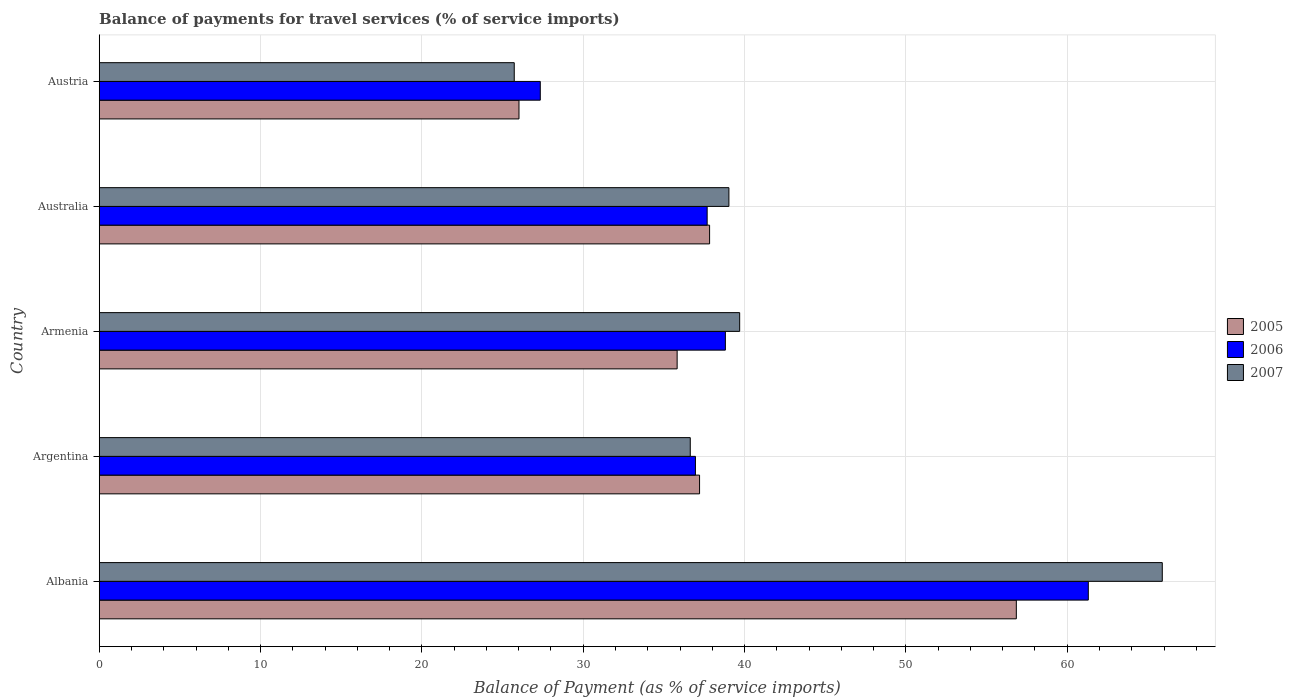How many different coloured bars are there?
Ensure brevity in your answer.  3. Are the number of bars per tick equal to the number of legend labels?
Offer a terse response. Yes. Are the number of bars on each tick of the Y-axis equal?
Offer a terse response. Yes. How many bars are there on the 1st tick from the bottom?
Provide a short and direct response. 3. What is the label of the 5th group of bars from the top?
Provide a succinct answer. Albania. What is the balance of payments for travel services in 2006 in Argentina?
Provide a short and direct response. 36.96. Across all countries, what is the maximum balance of payments for travel services in 2006?
Provide a succinct answer. 61.31. Across all countries, what is the minimum balance of payments for travel services in 2005?
Your answer should be very brief. 26.02. In which country was the balance of payments for travel services in 2006 maximum?
Offer a very short reply. Albania. What is the total balance of payments for travel services in 2006 in the graph?
Keep it short and to the point. 202.1. What is the difference between the balance of payments for travel services in 2005 in Argentina and that in Austria?
Make the answer very short. 11.19. What is the difference between the balance of payments for travel services in 2006 in Armenia and the balance of payments for travel services in 2005 in Austria?
Your answer should be very brief. 12.79. What is the average balance of payments for travel services in 2007 per country?
Keep it short and to the point. 41.4. What is the difference between the balance of payments for travel services in 2005 and balance of payments for travel services in 2006 in Austria?
Your response must be concise. -1.32. In how many countries, is the balance of payments for travel services in 2007 greater than 8 %?
Your answer should be compact. 5. What is the ratio of the balance of payments for travel services in 2006 in Argentina to that in Austria?
Keep it short and to the point. 1.35. Is the balance of payments for travel services in 2007 in Argentina less than that in Austria?
Offer a very short reply. No. What is the difference between the highest and the second highest balance of payments for travel services in 2007?
Your answer should be very brief. 26.19. What is the difference between the highest and the lowest balance of payments for travel services in 2005?
Provide a succinct answer. 30.83. What does the 1st bar from the bottom in Albania represents?
Your answer should be compact. 2005. Is it the case that in every country, the sum of the balance of payments for travel services in 2007 and balance of payments for travel services in 2006 is greater than the balance of payments for travel services in 2005?
Ensure brevity in your answer.  Yes. Are all the bars in the graph horizontal?
Provide a short and direct response. Yes. What is the difference between two consecutive major ticks on the X-axis?
Your response must be concise. 10. Are the values on the major ticks of X-axis written in scientific E-notation?
Your answer should be very brief. No. Where does the legend appear in the graph?
Ensure brevity in your answer.  Center right. What is the title of the graph?
Ensure brevity in your answer.  Balance of payments for travel services (% of service imports). What is the label or title of the X-axis?
Make the answer very short. Balance of Payment (as % of service imports). What is the Balance of Payment (as % of service imports) of 2005 in Albania?
Your answer should be very brief. 56.85. What is the Balance of Payment (as % of service imports) in 2006 in Albania?
Give a very brief answer. 61.31. What is the Balance of Payment (as % of service imports) in 2007 in Albania?
Your answer should be very brief. 65.89. What is the Balance of Payment (as % of service imports) of 2005 in Argentina?
Ensure brevity in your answer.  37.21. What is the Balance of Payment (as % of service imports) of 2006 in Argentina?
Ensure brevity in your answer.  36.96. What is the Balance of Payment (as % of service imports) of 2007 in Argentina?
Ensure brevity in your answer.  36.64. What is the Balance of Payment (as % of service imports) in 2005 in Armenia?
Provide a succinct answer. 35.82. What is the Balance of Payment (as % of service imports) of 2006 in Armenia?
Keep it short and to the point. 38.81. What is the Balance of Payment (as % of service imports) in 2007 in Armenia?
Your response must be concise. 39.7. What is the Balance of Payment (as % of service imports) in 2005 in Australia?
Keep it short and to the point. 37.83. What is the Balance of Payment (as % of service imports) in 2006 in Australia?
Your answer should be very brief. 37.68. What is the Balance of Payment (as % of service imports) in 2007 in Australia?
Offer a very short reply. 39.03. What is the Balance of Payment (as % of service imports) in 2005 in Austria?
Your answer should be compact. 26.02. What is the Balance of Payment (as % of service imports) of 2006 in Austria?
Keep it short and to the point. 27.34. What is the Balance of Payment (as % of service imports) of 2007 in Austria?
Offer a very short reply. 25.73. Across all countries, what is the maximum Balance of Payment (as % of service imports) of 2005?
Offer a terse response. 56.85. Across all countries, what is the maximum Balance of Payment (as % of service imports) of 2006?
Offer a very short reply. 61.31. Across all countries, what is the maximum Balance of Payment (as % of service imports) of 2007?
Ensure brevity in your answer.  65.89. Across all countries, what is the minimum Balance of Payment (as % of service imports) in 2005?
Keep it short and to the point. 26.02. Across all countries, what is the minimum Balance of Payment (as % of service imports) of 2006?
Your response must be concise. 27.34. Across all countries, what is the minimum Balance of Payment (as % of service imports) of 2007?
Your response must be concise. 25.73. What is the total Balance of Payment (as % of service imports) of 2005 in the graph?
Keep it short and to the point. 193.73. What is the total Balance of Payment (as % of service imports) in 2006 in the graph?
Your answer should be compact. 202.1. What is the total Balance of Payment (as % of service imports) of 2007 in the graph?
Provide a short and direct response. 206.98. What is the difference between the Balance of Payment (as % of service imports) in 2005 in Albania and that in Argentina?
Make the answer very short. 19.64. What is the difference between the Balance of Payment (as % of service imports) in 2006 in Albania and that in Argentina?
Offer a very short reply. 24.35. What is the difference between the Balance of Payment (as % of service imports) of 2007 in Albania and that in Argentina?
Your response must be concise. 29.26. What is the difference between the Balance of Payment (as % of service imports) of 2005 in Albania and that in Armenia?
Keep it short and to the point. 21.02. What is the difference between the Balance of Payment (as % of service imports) in 2006 in Albania and that in Armenia?
Give a very brief answer. 22.5. What is the difference between the Balance of Payment (as % of service imports) of 2007 in Albania and that in Armenia?
Your answer should be compact. 26.19. What is the difference between the Balance of Payment (as % of service imports) of 2005 in Albania and that in Australia?
Offer a terse response. 19.01. What is the difference between the Balance of Payment (as % of service imports) of 2006 in Albania and that in Australia?
Give a very brief answer. 23.63. What is the difference between the Balance of Payment (as % of service imports) of 2007 in Albania and that in Australia?
Provide a short and direct response. 26.86. What is the difference between the Balance of Payment (as % of service imports) in 2005 in Albania and that in Austria?
Your response must be concise. 30.83. What is the difference between the Balance of Payment (as % of service imports) in 2006 in Albania and that in Austria?
Make the answer very short. 33.97. What is the difference between the Balance of Payment (as % of service imports) of 2007 in Albania and that in Austria?
Ensure brevity in your answer.  40.17. What is the difference between the Balance of Payment (as % of service imports) in 2005 in Argentina and that in Armenia?
Keep it short and to the point. 1.39. What is the difference between the Balance of Payment (as % of service imports) in 2006 in Argentina and that in Armenia?
Offer a terse response. -1.86. What is the difference between the Balance of Payment (as % of service imports) of 2007 in Argentina and that in Armenia?
Your response must be concise. -3.06. What is the difference between the Balance of Payment (as % of service imports) in 2005 in Argentina and that in Australia?
Provide a short and direct response. -0.62. What is the difference between the Balance of Payment (as % of service imports) in 2006 in Argentina and that in Australia?
Provide a succinct answer. -0.73. What is the difference between the Balance of Payment (as % of service imports) in 2007 in Argentina and that in Australia?
Offer a very short reply. -2.4. What is the difference between the Balance of Payment (as % of service imports) of 2005 in Argentina and that in Austria?
Your answer should be very brief. 11.19. What is the difference between the Balance of Payment (as % of service imports) of 2006 in Argentina and that in Austria?
Offer a terse response. 9.62. What is the difference between the Balance of Payment (as % of service imports) in 2007 in Argentina and that in Austria?
Give a very brief answer. 10.91. What is the difference between the Balance of Payment (as % of service imports) of 2005 in Armenia and that in Australia?
Offer a terse response. -2.01. What is the difference between the Balance of Payment (as % of service imports) of 2006 in Armenia and that in Australia?
Offer a very short reply. 1.13. What is the difference between the Balance of Payment (as % of service imports) in 2007 in Armenia and that in Australia?
Offer a very short reply. 0.67. What is the difference between the Balance of Payment (as % of service imports) of 2005 in Armenia and that in Austria?
Ensure brevity in your answer.  9.8. What is the difference between the Balance of Payment (as % of service imports) of 2006 in Armenia and that in Austria?
Provide a short and direct response. 11.47. What is the difference between the Balance of Payment (as % of service imports) of 2007 in Armenia and that in Austria?
Make the answer very short. 13.97. What is the difference between the Balance of Payment (as % of service imports) of 2005 in Australia and that in Austria?
Make the answer very short. 11.82. What is the difference between the Balance of Payment (as % of service imports) of 2006 in Australia and that in Austria?
Offer a very short reply. 10.34. What is the difference between the Balance of Payment (as % of service imports) of 2007 in Australia and that in Austria?
Your answer should be compact. 13.31. What is the difference between the Balance of Payment (as % of service imports) in 2005 in Albania and the Balance of Payment (as % of service imports) in 2006 in Argentina?
Give a very brief answer. 19.89. What is the difference between the Balance of Payment (as % of service imports) of 2005 in Albania and the Balance of Payment (as % of service imports) of 2007 in Argentina?
Your answer should be very brief. 20.21. What is the difference between the Balance of Payment (as % of service imports) of 2006 in Albania and the Balance of Payment (as % of service imports) of 2007 in Argentina?
Offer a very short reply. 24.67. What is the difference between the Balance of Payment (as % of service imports) of 2005 in Albania and the Balance of Payment (as % of service imports) of 2006 in Armenia?
Your answer should be compact. 18.03. What is the difference between the Balance of Payment (as % of service imports) of 2005 in Albania and the Balance of Payment (as % of service imports) of 2007 in Armenia?
Your response must be concise. 17.15. What is the difference between the Balance of Payment (as % of service imports) in 2006 in Albania and the Balance of Payment (as % of service imports) in 2007 in Armenia?
Provide a short and direct response. 21.61. What is the difference between the Balance of Payment (as % of service imports) in 2005 in Albania and the Balance of Payment (as % of service imports) in 2006 in Australia?
Your answer should be very brief. 19.16. What is the difference between the Balance of Payment (as % of service imports) of 2005 in Albania and the Balance of Payment (as % of service imports) of 2007 in Australia?
Offer a terse response. 17.82. What is the difference between the Balance of Payment (as % of service imports) in 2006 in Albania and the Balance of Payment (as % of service imports) in 2007 in Australia?
Give a very brief answer. 22.28. What is the difference between the Balance of Payment (as % of service imports) of 2005 in Albania and the Balance of Payment (as % of service imports) of 2006 in Austria?
Your response must be concise. 29.51. What is the difference between the Balance of Payment (as % of service imports) in 2005 in Albania and the Balance of Payment (as % of service imports) in 2007 in Austria?
Keep it short and to the point. 31.12. What is the difference between the Balance of Payment (as % of service imports) of 2006 in Albania and the Balance of Payment (as % of service imports) of 2007 in Austria?
Your answer should be very brief. 35.58. What is the difference between the Balance of Payment (as % of service imports) in 2005 in Argentina and the Balance of Payment (as % of service imports) in 2006 in Armenia?
Provide a short and direct response. -1.6. What is the difference between the Balance of Payment (as % of service imports) in 2005 in Argentina and the Balance of Payment (as % of service imports) in 2007 in Armenia?
Provide a short and direct response. -2.49. What is the difference between the Balance of Payment (as % of service imports) in 2006 in Argentina and the Balance of Payment (as % of service imports) in 2007 in Armenia?
Your response must be concise. -2.74. What is the difference between the Balance of Payment (as % of service imports) of 2005 in Argentina and the Balance of Payment (as % of service imports) of 2006 in Australia?
Give a very brief answer. -0.47. What is the difference between the Balance of Payment (as % of service imports) in 2005 in Argentina and the Balance of Payment (as % of service imports) in 2007 in Australia?
Make the answer very short. -1.82. What is the difference between the Balance of Payment (as % of service imports) of 2006 in Argentina and the Balance of Payment (as % of service imports) of 2007 in Australia?
Your answer should be compact. -2.07. What is the difference between the Balance of Payment (as % of service imports) of 2005 in Argentina and the Balance of Payment (as % of service imports) of 2006 in Austria?
Offer a terse response. 9.87. What is the difference between the Balance of Payment (as % of service imports) in 2005 in Argentina and the Balance of Payment (as % of service imports) in 2007 in Austria?
Give a very brief answer. 11.49. What is the difference between the Balance of Payment (as % of service imports) of 2006 in Argentina and the Balance of Payment (as % of service imports) of 2007 in Austria?
Provide a short and direct response. 11.23. What is the difference between the Balance of Payment (as % of service imports) of 2005 in Armenia and the Balance of Payment (as % of service imports) of 2006 in Australia?
Provide a succinct answer. -1.86. What is the difference between the Balance of Payment (as % of service imports) of 2005 in Armenia and the Balance of Payment (as % of service imports) of 2007 in Australia?
Provide a short and direct response. -3.21. What is the difference between the Balance of Payment (as % of service imports) in 2006 in Armenia and the Balance of Payment (as % of service imports) in 2007 in Australia?
Your answer should be compact. -0.22. What is the difference between the Balance of Payment (as % of service imports) of 2005 in Armenia and the Balance of Payment (as % of service imports) of 2006 in Austria?
Make the answer very short. 8.48. What is the difference between the Balance of Payment (as % of service imports) of 2005 in Armenia and the Balance of Payment (as % of service imports) of 2007 in Austria?
Keep it short and to the point. 10.1. What is the difference between the Balance of Payment (as % of service imports) in 2006 in Armenia and the Balance of Payment (as % of service imports) in 2007 in Austria?
Your answer should be compact. 13.09. What is the difference between the Balance of Payment (as % of service imports) in 2005 in Australia and the Balance of Payment (as % of service imports) in 2006 in Austria?
Your response must be concise. 10.49. What is the difference between the Balance of Payment (as % of service imports) of 2005 in Australia and the Balance of Payment (as % of service imports) of 2007 in Austria?
Keep it short and to the point. 12.11. What is the difference between the Balance of Payment (as % of service imports) in 2006 in Australia and the Balance of Payment (as % of service imports) in 2007 in Austria?
Your answer should be very brief. 11.96. What is the average Balance of Payment (as % of service imports) of 2005 per country?
Keep it short and to the point. 38.75. What is the average Balance of Payment (as % of service imports) in 2006 per country?
Your response must be concise. 40.42. What is the average Balance of Payment (as % of service imports) of 2007 per country?
Ensure brevity in your answer.  41.4. What is the difference between the Balance of Payment (as % of service imports) in 2005 and Balance of Payment (as % of service imports) in 2006 in Albania?
Ensure brevity in your answer.  -4.46. What is the difference between the Balance of Payment (as % of service imports) of 2005 and Balance of Payment (as % of service imports) of 2007 in Albania?
Give a very brief answer. -9.05. What is the difference between the Balance of Payment (as % of service imports) in 2006 and Balance of Payment (as % of service imports) in 2007 in Albania?
Your answer should be compact. -4.58. What is the difference between the Balance of Payment (as % of service imports) of 2005 and Balance of Payment (as % of service imports) of 2006 in Argentina?
Your answer should be compact. 0.25. What is the difference between the Balance of Payment (as % of service imports) in 2005 and Balance of Payment (as % of service imports) in 2007 in Argentina?
Provide a short and direct response. 0.58. What is the difference between the Balance of Payment (as % of service imports) of 2006 and Balance of Payment (as % of service imports) of 2007 in Argentina?
Keep it short and to the point. 0.32. What is the difference between the Balance of Payment (as % of service imports) in 2005 and Balance of Payment (as % of service imports) in 2006 in Armenia?
Make the answer very short. -2.99. What is the difference between the Balance of Payment (as % of service imports) in 2005 and Balance of Payment (as % of service imports) in 2007 in Armenia?
Your response must be concise. -3.88. What is the difference between the Balance of Payment (as % of service imports) of 2006 and Balance of Payment (as % of service imports) of 2007 in Armenia?
Provide a short and direct response. -0.89. What is the difference between the Balance of Payment (as % of service imports) of 2005 and Balance of Payment (as % of service imports) of 2006 in Australia?
Provide a short and direct response. 0.15. What is the difference between the Balance of Payment (as % of service imports) of 2005 and Balance of Payment (as % of service imports) of 2007 in Australia?
Ensure brevity in your answer.  -1.2. What is the difference between the Balance of Payment (as % of service imports) in 2006 and Balance of Payment (as % of service imports) in 2007 in Australia?
Your response must be concise. -1.35. What is the difference between the Balance of Payment (as % of service imports) in 2005 and Balance of Payment (as % of service imports) in 2006 in Austria?
Your answer should be compact. -1.32. What is the difference between the Balance of Payment (as % of service imports) in 2005 and Balance of Payment (as % of service imports) in 2007 in Austria?
Provide a short and direct response. 0.29. What is the difference between the Balance of Payment (as % of service imports) of 2006 and Balance of Payment (as % of service imports) of 2007 in Austria?
Provide a short and direct response. 1.61. What is the ratio of the Balance of Payment (as % of service imports) of 2005 in Albania to that in Argentina?
Your response must be concise. 1.53. What is the ratio of the Balance of Payment (as % of service imports) in 2006 in Albania to that in Argentina?
Provide a succinct answer. 1.66. What is the ratio of the Balance of Payment (as % of service imports) of 2007 in Albania to that in Argentina?
Offer a terse response. 1.8. What is the ratio of the Balance of Payment (as % of service imports) in 2005 in Albania to that in Armenia?
Provide a short and direct response. 1.59. What is the ratio of the Balance of Payment (as % of service imports) in 2006 in Albania to that in Armenia?
Provide a short and direct response. 1.58. What is the ratio of the Balance of Payment (as % of service imports) in 2007 in Albania to that in Armenia?
Keep it short and to the point. 1.66. What is the ratio of the Balance of Payment (as % of service imports) of 2005 in Albania to that in Australia?
Ensure brevity in your answer.  1.5. What is the ratio of the Balance of Payment (as % of service imports) of 2006 in Albania to that in Australia?
Offer a very short reply. 1.63. What is the ratio of the Balance of Payment (as % of service imports) in 2007 in Albania to that in Australia?
Make the answer very short. 1.69. What is the ratio of the Balance of Payment (as % of service imports) of 2005 in Albania to that in Austria?
Your response must be concise. 2.18. What is the ratio of the Balance of Payment (as % of service imports) of 2006 in Albania to that in Austria?
Keep it short and to the point. 2.24. What is the ratio of the Balance of Payment (as % of service imports) in 2007 in Albania to that in Austria?
Your response must be concise. 2.56. What is the ratio of the Balance of Payment (as % of service imports) of 2005 in Argentina to that in Armenia?
Provide a short and direct response. 1.04. What is the ratio of the Balance of Payment (as % of service imports) in 2006 in Argentina to that in Armenia?
Provide a short and direct response. 0.95. What is the ratio of the Balance of Payment (as % of service imports) of 2007 in Argentina to that in Armenia?
Make the answer very short. 0.92. What is the ratio of the Balance of Payment (as % of service imports) in 2005 in Argentina to that in Australia?
Your answer should be very brief. 0.98. What is the ratio of the Balance of Payment (as % of service imports) of 2006 in Argentina to that in Australia?
Provide a succinct answer. 0.98. What is the ratio of the Balance of Payment (as % of service imports) of 2007 in Argentina to that in Australia?
Make the answer very short. 0.94. What is the ratio of the Balance of Payment (as % of service imports) in 2005 in Argentina to that in Austria?
Your response must be concise. 1.43. What is the ratio of the Balance of Payment (as % of service imports) of 2006 in Argentina to that in Austria?
Make the answer very short. 1.35. What is the ratio of the Balance of Payment (as % of service imports) in 2007 in Argentina to that in Austria?
Offer a very short reply. 1.42. What is the ratio of the Balance of Payment (as % of service imports) in 2005 in Armenia to that in Australia?
Offer a very short reply. 0.95. What is the ratio of the Balance of Payment (as % of service imports) in 2007 in Armenia to that in Australia?
Provide a succinct answer. 1.02. What is the ratio of the Balance of Payment (as % of service imports) in 2005 in Armenia to that in Austria?
Keep it short and to the point. 1.38. What is the ratio of the Balance of Payment (as % of service imports) in 2006 in Armenia to that in Austria?
Provide a short and direct response. 1.42. What is the ratio of the Balance of Payment (as % of service imports) of 2007 in Armenia to that in Austria?
Make the answer very short. 1.54. What is the ratio of the Balance of Payment (as % of service imports) in 2005 in Australia to that in Austria?
Offer a very short reply. 1.45. What is the ratio of the Balance of Payment (as % of service imports) in 2006 in Australia to that in Austria?
Provide a short and direct response. 1.38. What is the ratio of the Balance of Payment (as % of service imports) in 2007 in Australia to that in Austria?
Provide a short and direct response. 1.52. What is the difference between the highest and the second highest Balance of Payment (as % of service imports) of 2005?
Make the answer very short. 19.01. What is the difference between the highest and the second highest Balance of Payment (as % of service imports) in 2006?
Provide a succinct answer. 22.5. What is the difference between the highest and the second highest Balance of Payment (as % of service imports) of 2007?
Provide a short and direct response. 26.19. What is the difference between the highest and the lowest Balance of Payment (as % of service imports) of 2005?
Offer a terse response. 30.83. What is the difference between the highest and the lowest Balance of Payment (as % of service imports) of 2006?
Offer a very short reply. 33.97. What is the difference between the highest and the lowest Balance of Payment (as % of service imports) in 2007?
Offer a terse response. 40.17. 